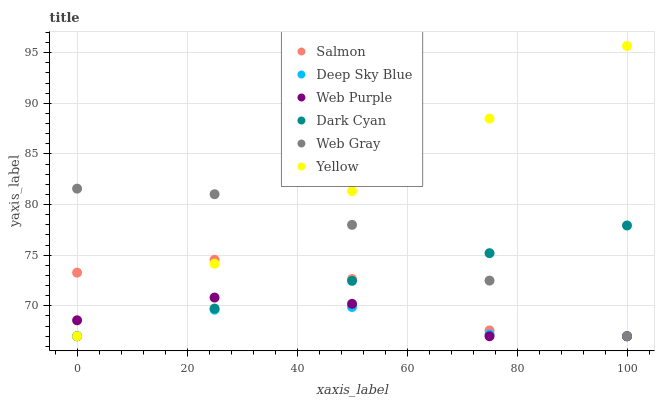Does Deep Sky Blue have the minimum area under the curve?
Answer yes or no. Yes. Does Yellow have the maximum area under the curve?
Answer yes or no. Yes. Does Salmon have the minimum area under the curve?
Answer yes or no. No. Does Salmon have the maximum area under the curve?
Answer yes or no. No. Is Dark Cyan the smoothest?
Answer yes or no. Yes. Is Salmon the roughest?
Answer yes or no. Yes. Is Yellow the smoothest?
Answer yes or no. No. Is Yellow the roughest?
Answer yes or no. No. Does Web Gray have the lowest value?
Answer yes or no. Yes. Does Yellow have the highest value?
Answer yes or no. Yes. Does Salmon have the highest value?
Answer yes or no. No. Does Web Purple intersect Web Gray?
Answer yes or no. Yes. Is Web Purple less than Web Gray?
Answer yes or no. No. Is Web Purple greater than Web Gray?
Answer yes or no. No. 